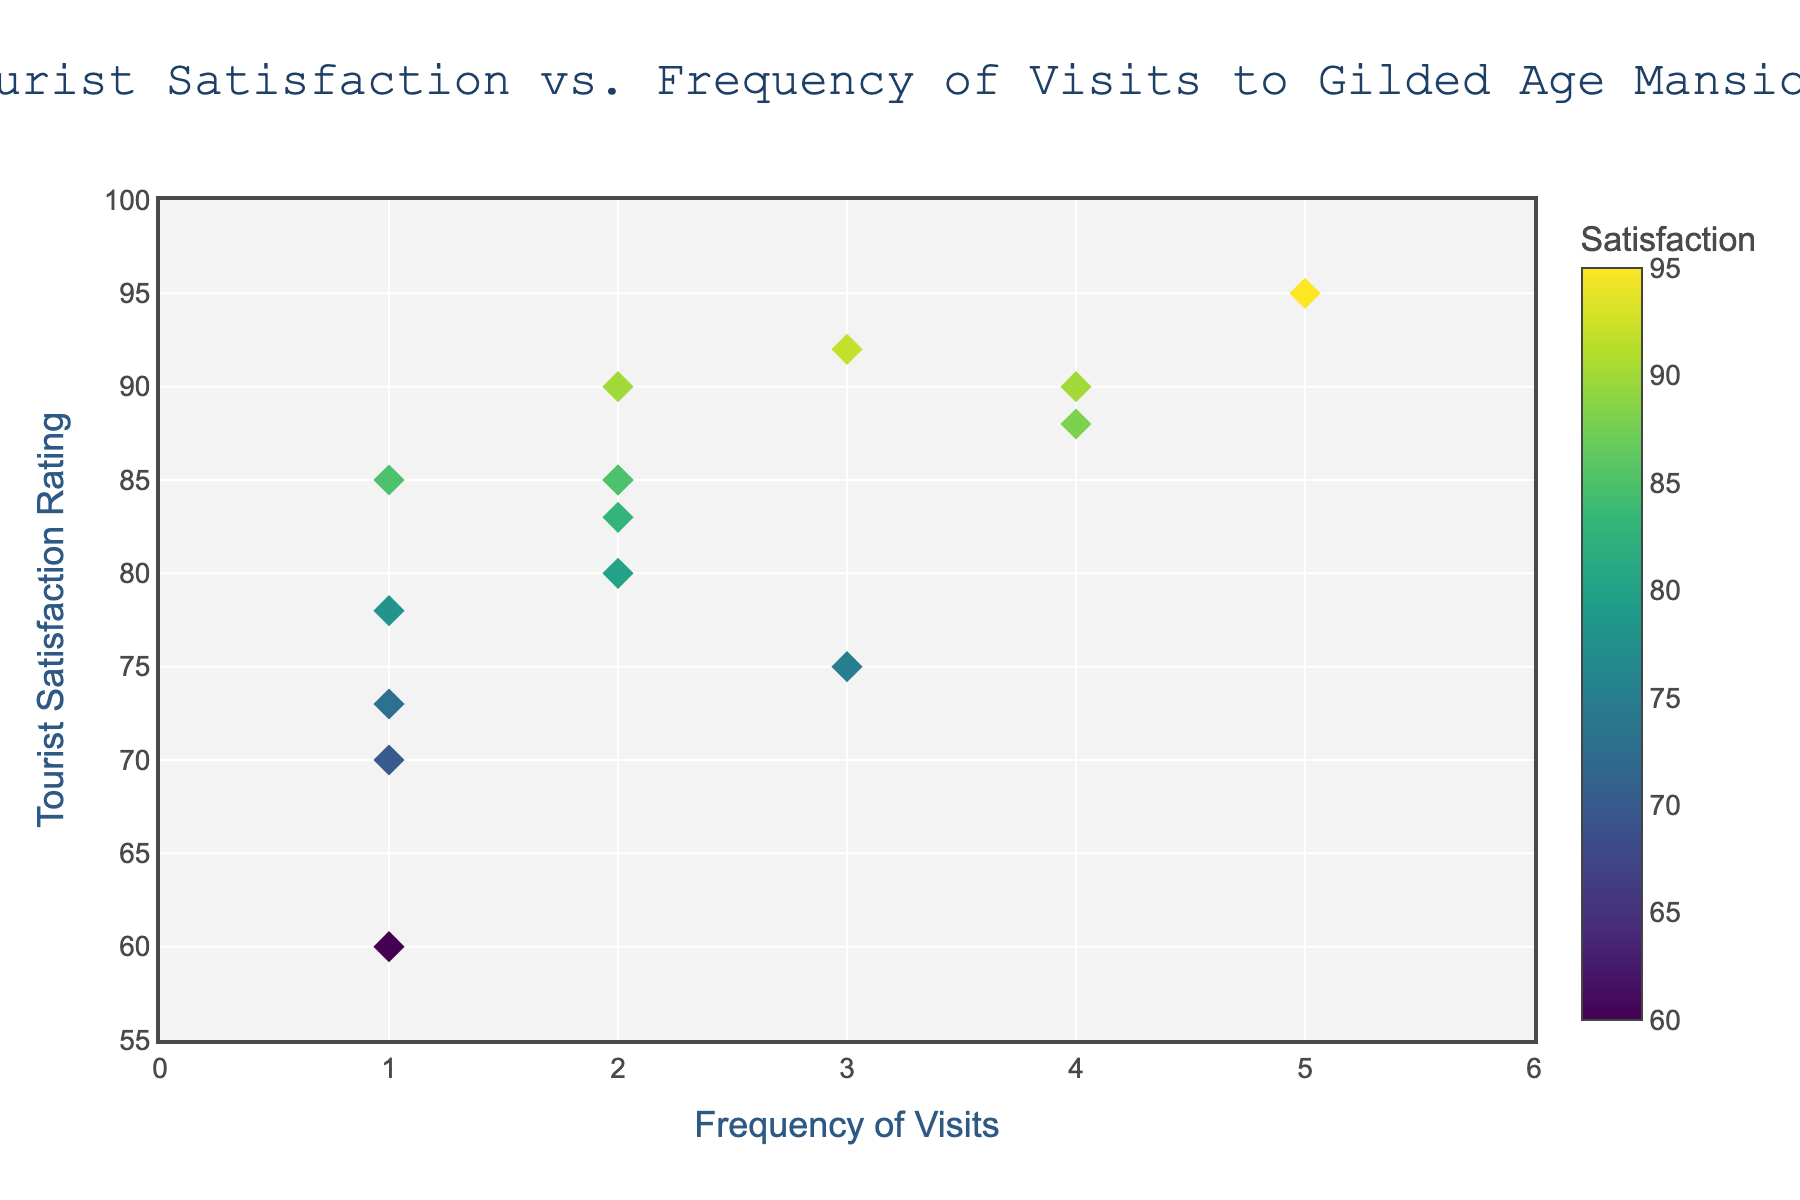How many data points are there in the scatter plot? Count the total number of markers present in the plot; each represents a unique data point from the dataset.
Answer: 15 What is the title of the scatter plot? Look at the text displayed at the top center of the scatter plot, which summarizes the contents or purpose of the chart.
Answer: Tourist Satisfaction vs. Frequency of Visits to Gilded Age Mansions What are the axis titles of the scatter plot? Identify the text labels along the horizontal and vertical axes; these labels describe the variables being plotted.
Answer: Frequency of Visits and Tourist Satisfaction Rating What is the tourist satisfaction rating for someone who has visited the mansions three times? Find the marker with x-coordinate equal to 3 and read its corresponding y-coordinate, which represents the tourist satisfaction rating.
Answer: 75 or 92 Which frequency of visits has the highest recorded tourist satisfaction rating, and what is that rating? Look for the marker with the highest y-coordinate and note its x-coordinate, representing the frequency of visits, and the y-coordinate, representing the satisfaction rating.
Answer: 5 and 95 Is there a general trend between tourist satisfaction and frequency of visits? Observe the overall distribution of the markers in the scatter plot to determine if there is a noticeable pattern indicating a positive, negative, or no correlation.
Answer: Generally positive What is the average tourist satisfaction rating for tourists who visited the mansions once? Identify all markers where the x-coordinate is 1, sum their y-coordinates (satisfaction ratings), and divide by the number of such points.
Answer: 73.2 Which frequency of visits has the highest number of tourists recorded, and how many tourists fall into this category? Determine the x-coordinate with the most markers and count them.
Answer: 2 and 5 Compare the tourist satisfaction for those who visited the mansions twice versus four times. Which group has higher satisfaction on average? Identify the markers for x = 2 and x = 4, calculate the average y-coordinate for each group, and compare the averages.
Answer: Four times What color scale is used for the markers and what variable does it represent? Check the color information of the markers and their corresponding color bar title to understand the color representation.
Answer: Viridis and Tourist Satisfaction 